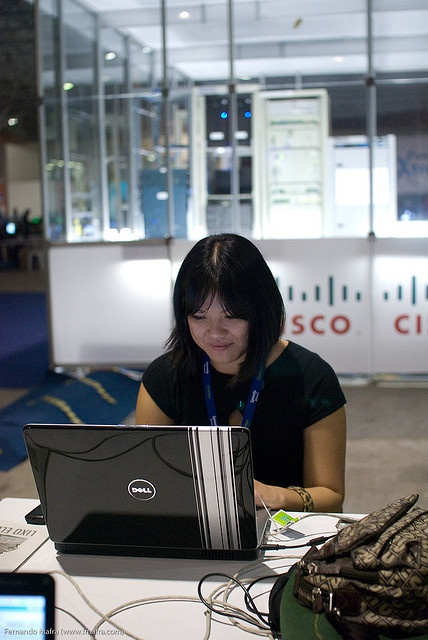Describe the objects in this image and their specific colors. I can see people in black, maroon, and gray tones, laptop in black, gray, darkgray, and lightgray tones, and handbag in black and gray tones in this image. 